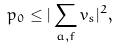<formula> <loc_0><loc_0><loc_500><loc_500>p _ { 0 } \leq | \sum _ { a , f } v _ { s } | ^ { 2 } ,</formula> 